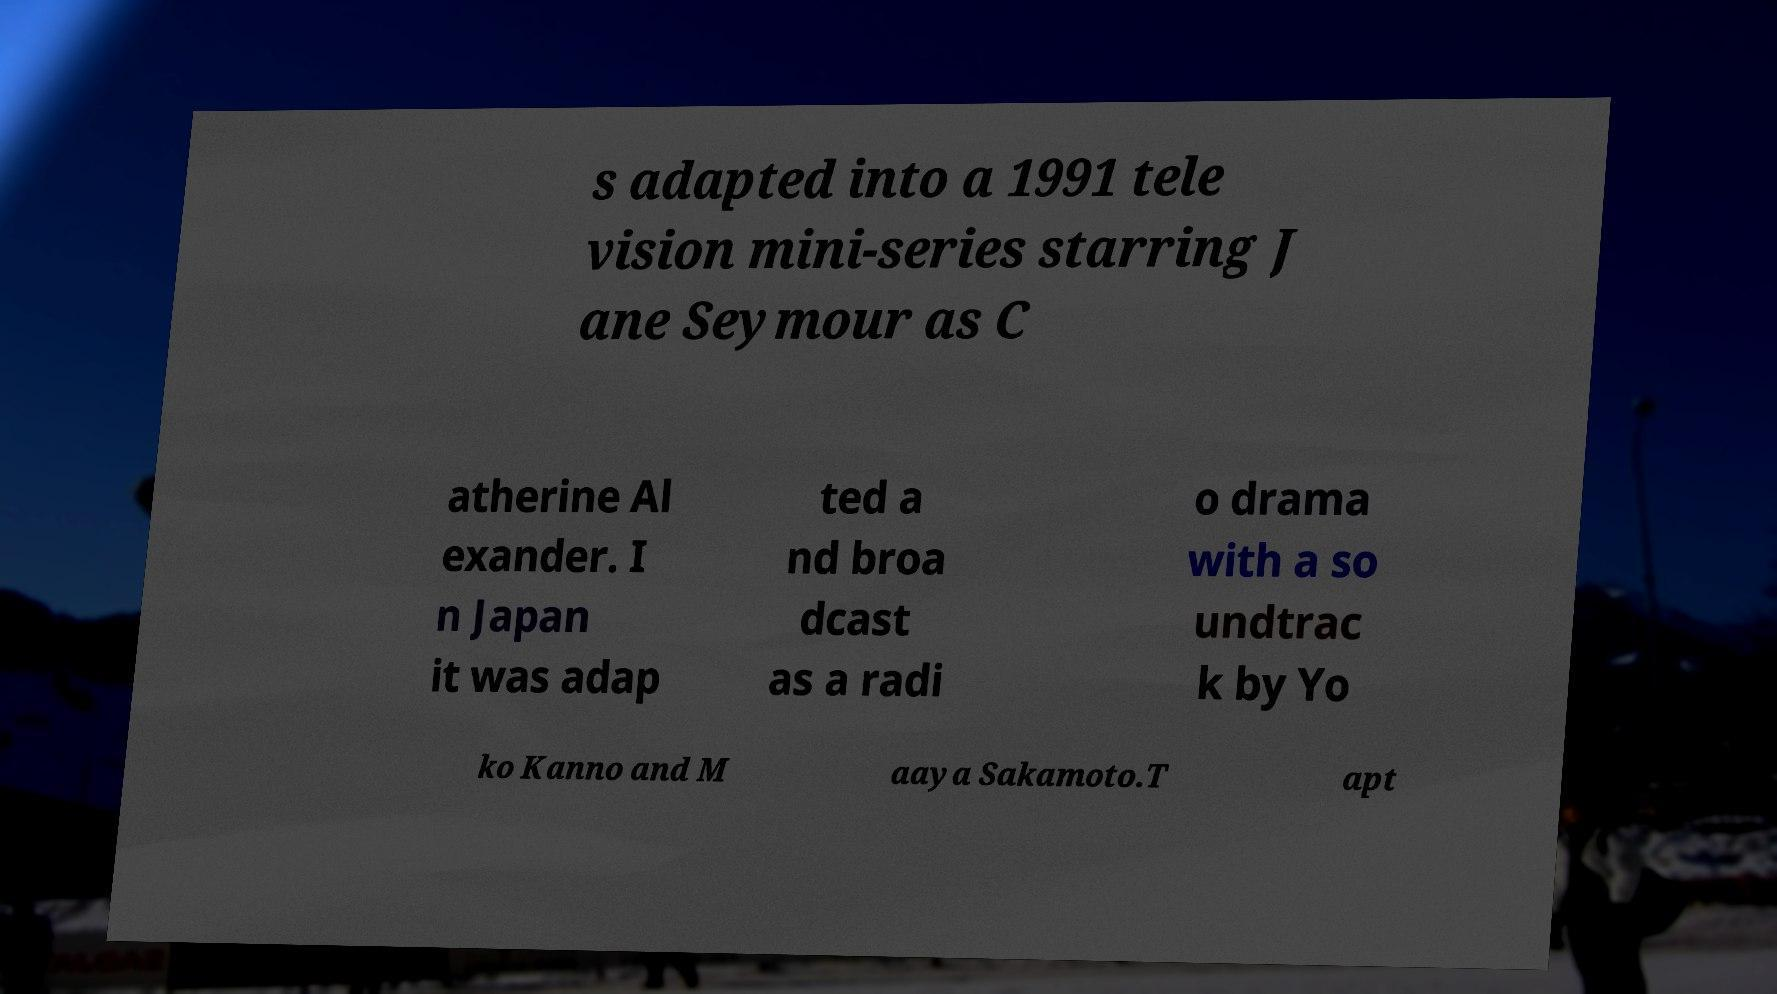For documentation purposes, I need the text within this image transcribed. Could you provide that? s adapted into a 1991 tele vision mini-series starring J ane Seymour as C atherine Al exander. I n Japan it was adap ted a nd broa dcast as a radi o drama with a so undtrac k by Yo ko Kanno and M aaya Sakamoto.T apt 